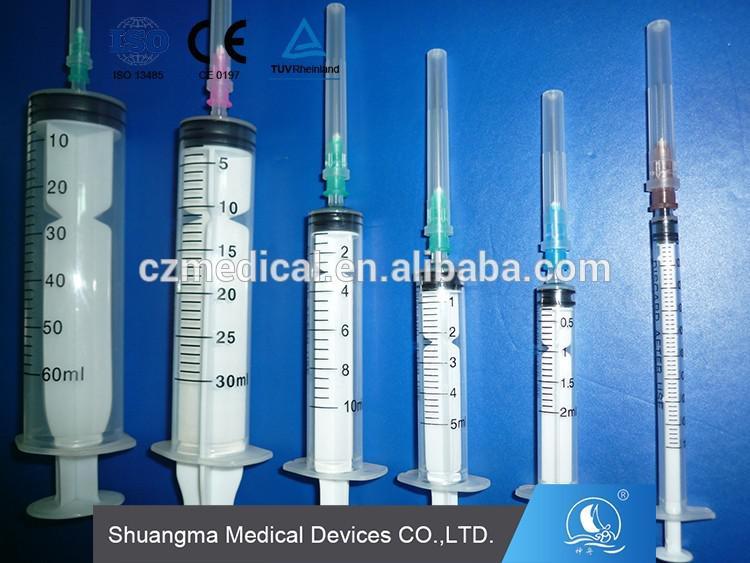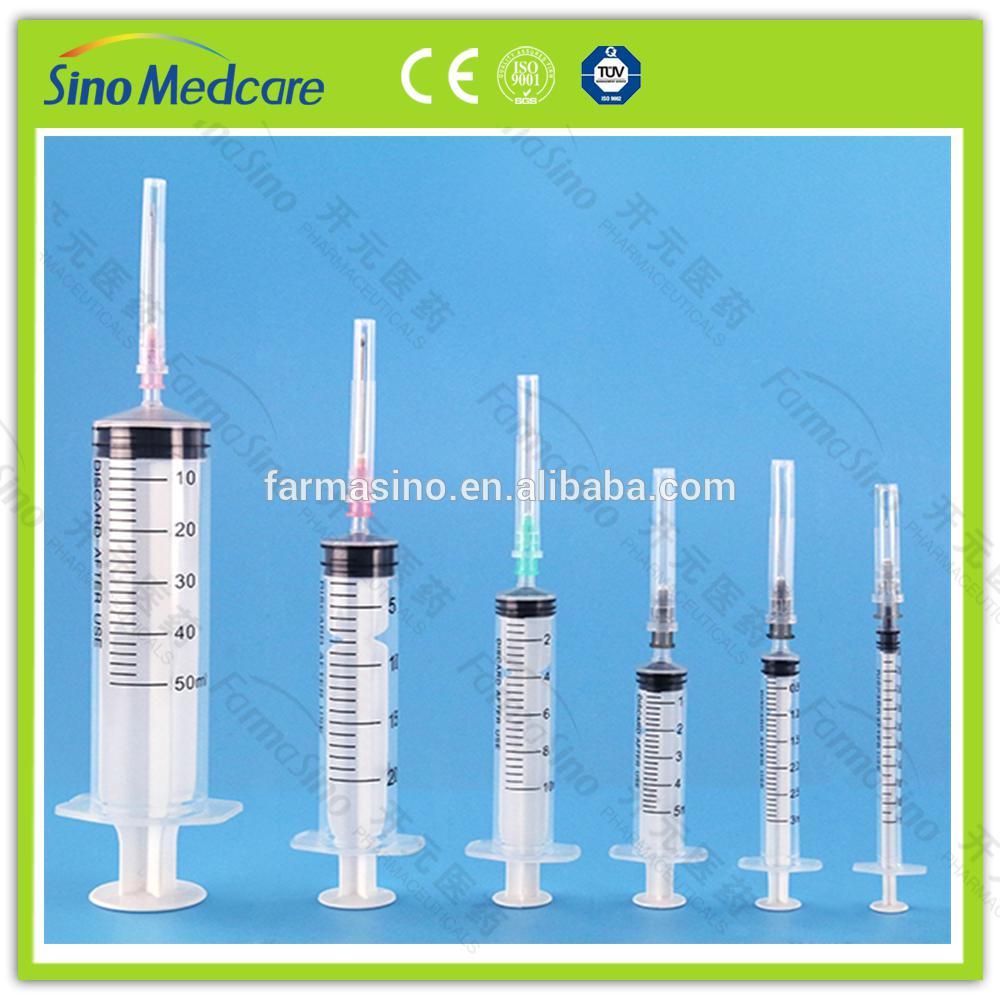The first image is the image on the left, the second image is the image on the right. For the images shown, is this caption "Each image shows syringes arranged in descending order of volume from left to right, on a blue background." true? Answer yes or no. Yes. The first image is the image on the left, the second image is the image on the right. For the images shown, is this caption "The left and right image contains the same number of syringes." true? Answer yes or no. Yes. 